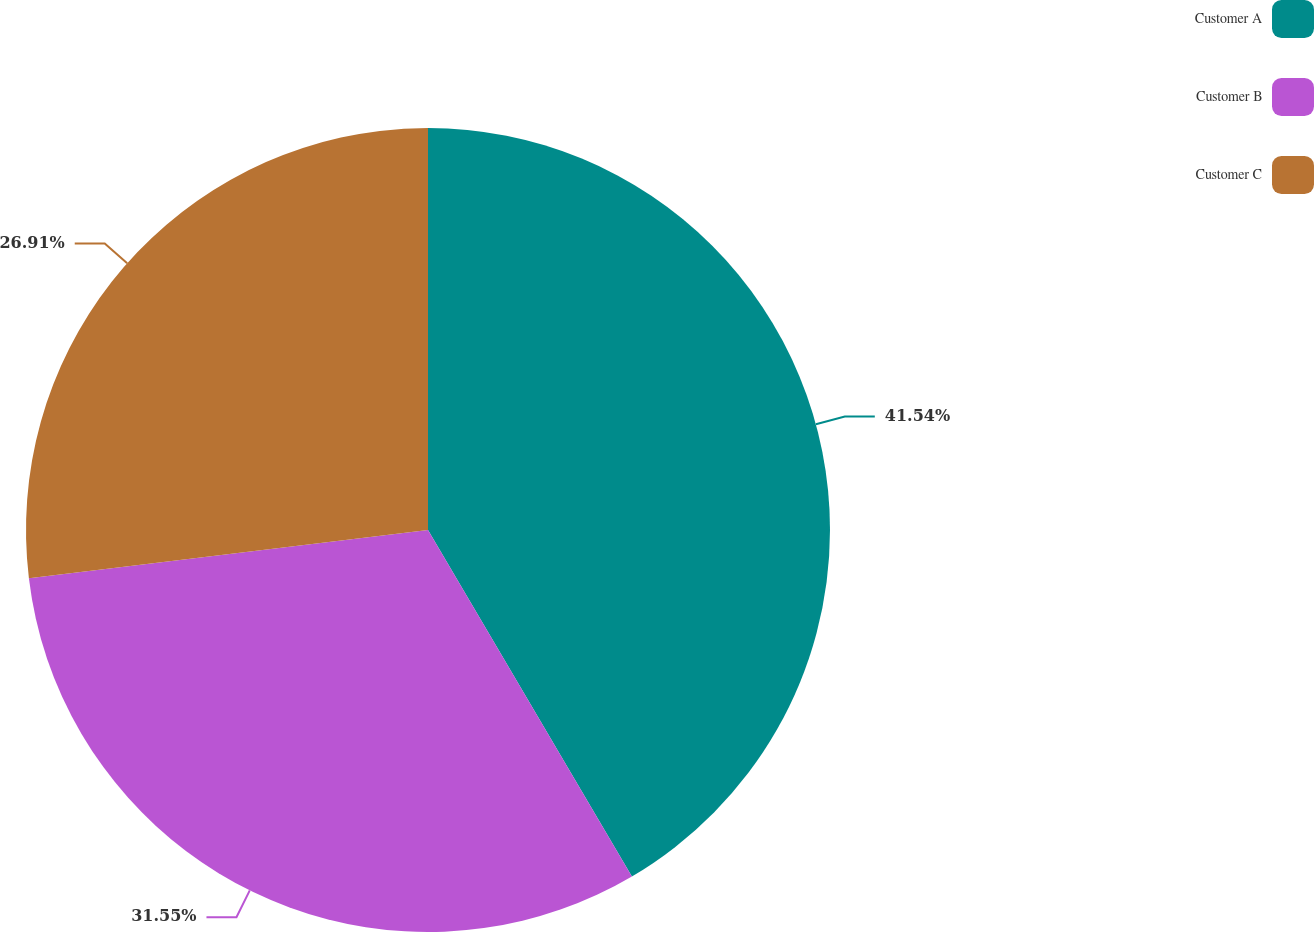Convert chart. <chart><loc_0><loc_0><loc_500><loc_500><pie_chart><fcel>Customer A<fcel>Customer B<fcel>Customer C<nl><fcel>41.53%<fcel>31.55%<fcel>26.91%<nl></chart> 